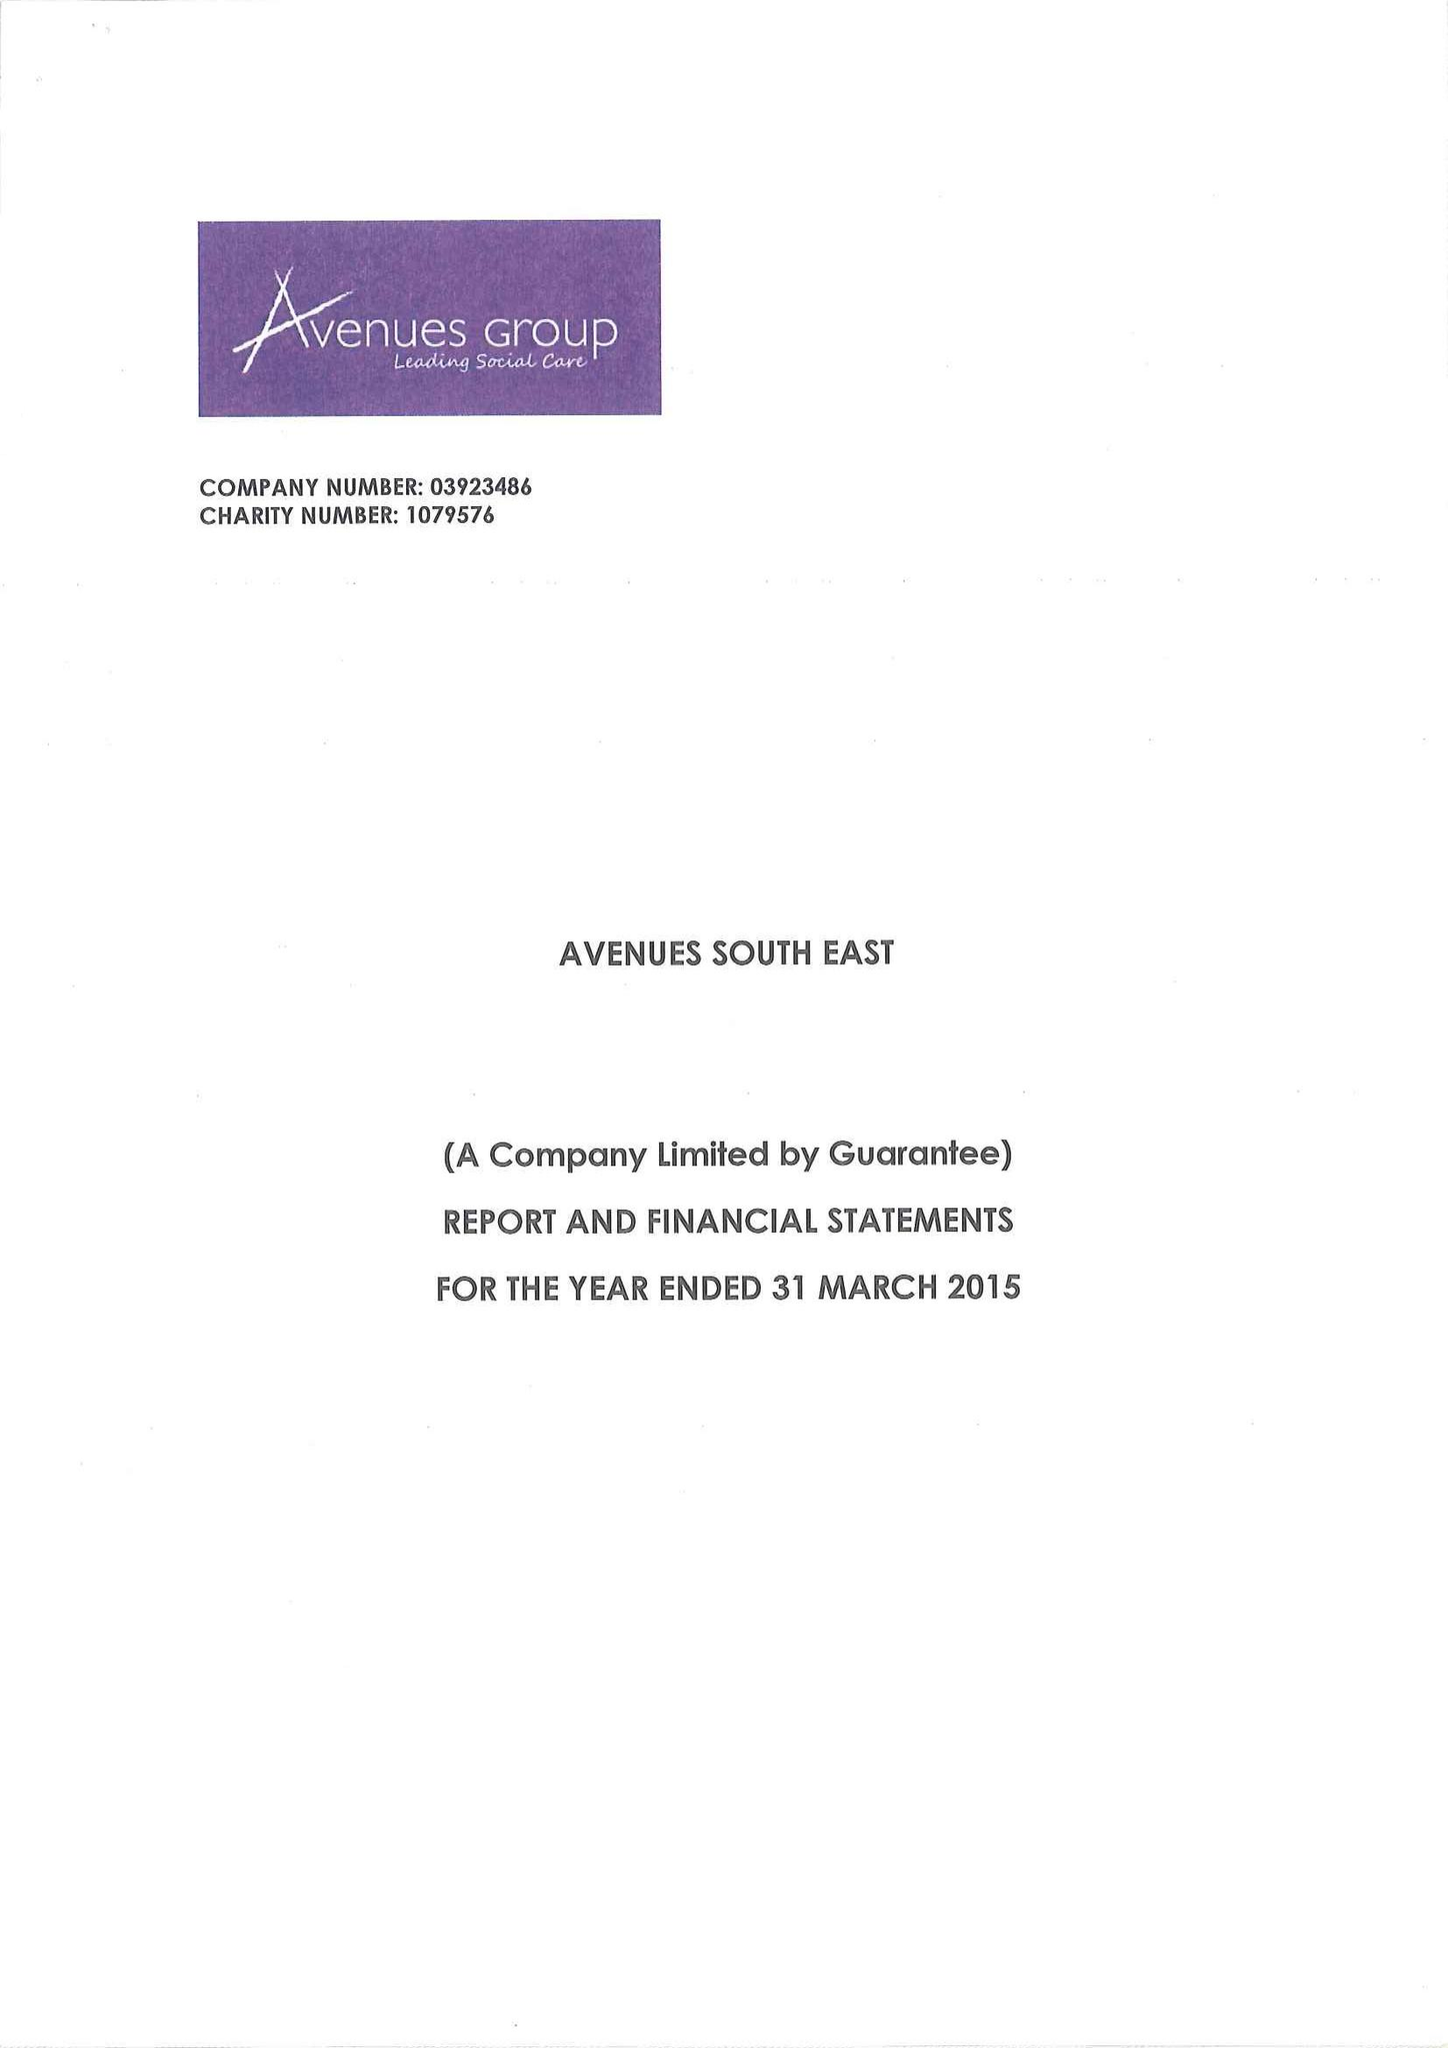What is the value for the spending_annually_in_british_pounds?
Answer the question using a single word or phrase. 13853020.00 